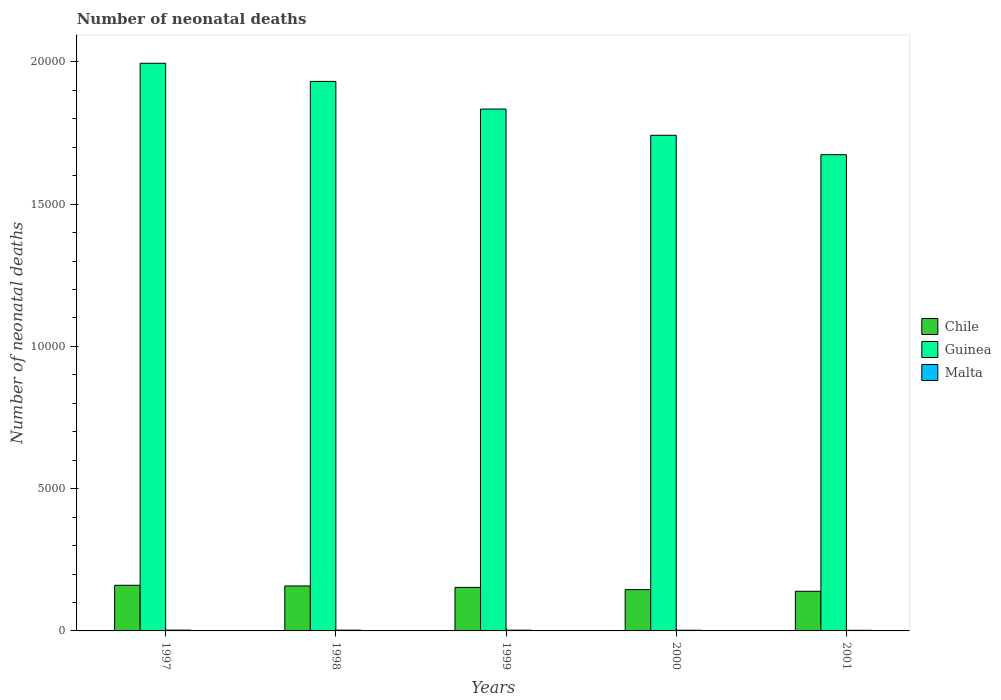How many different coloured bars are there?
Your answer should be compact. 3. How many groups of bars are there?
Make the answer very short. 5. Are the number of bars per tick equal to the number of legend labels?
Keep it short and to the point. Yes. What is the label of the 1st group of bars from the left?
Give a very brief answer. 1997. What is the number of neonatal deaths in in Guinea in 1999?
Provide a succinct answer. 1.83e+04. Across all years, what is the maximum number of neonatal deaths in in Malta?
Your response must be concise. 28. Across all years, what is the minimum number of neonatal deaths in in Malta?
Your response must be concise. 22. What is the total number of neonatal deaths in in Guinea in the graph?
Ensure brevity in your answer.  9.18e+04. What is the difference between the number of neonatal deaths in in Guinea in 2000 and that in 2001?
Ensure brevity in your answer.  682. What is the difference between the number of neonatal deaths in in Malta in 1997 and the number of neonatal deaths in in Guinea in 2001?
Provide a succinct answer. -1.67e+04. What is the average number of neonatal deaths in in Chile per year?
Ensure brevity in your answer.  1512. In the year 1998, what is the difference between the number of neonatal deaths in in Chile and number of neonatal deaths in in Guinea?
Provide a succinct answer. -1.77e+04. In how many years, is the number of neonatal deaths in in Guinea greater than 2000?
Your answer should be compact. 5. What is the ratio of the number of neonatal deaths in in Malta in 1998 to that in 1999?
Your response must be concise. 1.04. Is the number of neonatal deaths in in Guinea in 1998 less than that in 2000?
Your answer should be very brief. No. What is the difference between the highest and the lowest number of neonatal deaths in in Chile?
Ensure brevity in your answer.  210. Is the sum of the number of neonatal deaths in in Chile in 1998 and 1999 greater than the maximum number of neonatal deaths in in Guinea across all years?
Make the answer very short. No. What does the 1st bar from the left in 1999 represents?
Offer a terse response. Chile. What does the 2nd bar from the right in 1998 represents?
Offer a very short reply. Guinea. Is it the case that in every year, the sum of the number of neonatal deaths in in Malta and number of neonatal deaths in in Guinea is greater than the number of neonatal deaths in in Chile?
Give a very brief answer. Yes. How many years are there in the graph?
Ensure brevity in your answer.  5. What is the difference between two consecutive major ticks on the Y-axis?
Provide a succinct answer. 5000. Are the values on the major ticks of Y-axis written in scientific E-notation?
Offer a terse response. No. How many legend labels are there?
Offer a terse response. 3. What is the title of the graph?
Offer a terse response. Number of neonatal deaths. What is the label or title of the Y-axis?
Give a very brief answer. Number of neonatal deaths. What is the Number of neonatal deaths in Chile in 1997?
Offer a terse response. 1604. What is the Number of neonatal deaths of Guinea in 1997?
Your response must be concise. 2.00e+04. What is the Number of neonatal deaths in Chile in 1998?
Offer a very short reply. 1580. What is the Number of neonatal deaths of Guinea in 1998?
Provide a succinct answer. 1.93e+04. What is the Number of neonatal deaths in Chile in 1999?
Give a very brief answer. 1530. What is the Number of neonatal deaths in Guinea in 1999?
Offer a terse response. 1.83e+04. What is the Number of neonatal deaths in Malta in 1999?
Give a very brief answer. 26. What is the Number of neonatal deaths in Chile in 2000?
Ensure brevity in your answer.  1452. What is the Number of neonatal deaths in Guinea in 2000?
Offer a very short reply. 1.74e+04. What is the Number of neonatal deaths of Chile in 2001?
Ensure brevity in your answer.  1394. What is the Number of neonatal deaths of Guinea in 2001?
Your answer should be very brief. 1.67e+04. Across all years, what is the maximum Number of neonatal deaths of Chile?
Give a very brief answer. 1604. Across all years, what is the maximum Number of neonatal deaths in Guinea?
Give a very brief answer. 2.00e+04. Across all years, what is the maximum Number of neonatal deaths in Malta?
Offer a very short reply. 28. Across all years, what is the minimum Number of neonatal deaths of Chile?
Provide a succinct answer. 1394. Across all years, what is the minimum Number of neonatal deaths in Guinea?
Your answer should be compact. 1.67e+04. Across all years, what is the minimum Number of neonatal deaths in Malta?
Your response must be concise. 22. What is the total Number of neonatal deaths in Chile in the graph?
Provide a succinct answer. 7560. What is the total Number of neonatal deaths in Guinea in the graph?
Provide a short and direct response. 9.18e+04. What is the total Number of neonatal deaths of Malta in the graph?
Make the answer very short. 127. What is the difference between the Number of neonatal deaths of Guinea in 1997 and that in 1998?
Your answer should be compact. 637. What is the difference between the Number of neonatal deaths of Guinea in 1997 and that in 1999?
Provide a short and direct response. 1609. What is the difference between the Number of neonatal deaths in Malta in 1997 and that in 1999?
Keep it short and to the point. 2. What is the difference between the Number of neonatal deaths of Chile in 1997 and that in 2000?
Keep it short and to the point. 152. What is the difference between the Number of neonatal deaths of Guinea in 1997 and that in 2000?
Your response must be concise. 2531. What is the difference between the Number of neonatal deaths in Chile in 1997 and that in 2001?
Your response must be concise. 210. What is the difference between the Number of neonatal deaths of Guinea in 1997 and that in 2001?
Provide a short and direct response. 3213. What is the difference between the Number of neonatal deaths of Guinea in 1998 and that in 1999?
Keep it short and to the point. 972. What is the difference between the Number of neonatal deaths of Chile in 1998 and that in 2000?
Your answer should be compact. 128. What is the difference between the Number of neonatal deaths of Guinea in 1998 and that in 2000?
Your response must be concise. 1894. What is the difference between the Number of neonatal deaths of Chile in 1998 and that in 2001?
Your response must be concise. 186. What is the difference between the Number of neonatal deaths in Guinea in 1998 and that in 2001?
Ensure brevity in your answer.  2576. What is the difference between the Number of neonatal deaths of Guinea in 1999 and that in 2000?
Offer a very short reply. 922. What is the difference between the Number of neonatal deaths of Malta in 1999 and that in 2000?
Make the answer very short. 2. What is the difference between the Number of neonatal deaths of Chile in 1999 and that in 2001?
Provide a short and direct response. 136. What is the difference between the Number of neonatal deaths of Guinea in 1999 and that in 2001?
Give a very brief answer. 1604. What is the difference between the Number of neonatal deaths in Malta in 1999 and that in 2001?
Give a very brief answer. 4. What is the difference between the Number of neonatal deaths in Chile in 2000 and that in 2001?
Your answer should be compact. 58. What is the difference between the Number of neonatal deaths in Guinea in 2000 and that in 2001?
Provide a short and direct response. 682. What is the difference between the Number of neonatal deaths of Malta in 2000 and that in 2001?
Keep it short and to the point. 2. What is the difference between the Number of neonatal deaths in Chile in 1997 and the Number of neonatal deaths in Guinea in 1998?
Offer a terse response. -1.77e+04. What is the difference between the Number of neonatal deaths of Chile in 1997 and the Number of neonatal deaths of Malta in 1998?
Keep it short and to the point. 1577. What is the difference between the Number of neonatal deaths in Guinea in 1997 and the Number of neonatal deaths in Malta in 1998?
Keep it short and to the point. 1.99e+04. What is the difference between the Number of neonatal deaths in Chile in 1997 and the Number of neonatal deaths in Guinea in 1999?
Provide a succinct answer. -1.67e+04. What is the difference between the Number of neonatal deaths in Chile in 1997 and the Number of neonatal deaths in Malta in 1999?
Offer a very short reply. 1578. What is the difference between the Number of neonatal deaths of Guinea in 1997 and the Number of neonatal deaths of Malta in 1999?
Give a very brief answer. 1.99e+04. What is the difference between the Number of neonatal deaths of Chile in 1997 and the Number of neonatal deaths of Guinea in 2000?
Provide a short and direct response. -1.58e+04. What is the difference between the Number of neonatal deaths of Chile in 1997 and the Number of neonatal deaths of Malta in 2000?
Provide a short and direct response. 1580. What is the difference between the Number of neonatal deaths in Guinea in 1997 and the Number of neonatal deaths in Malta in 2000?
Give a very brief answer. 1.99e+04. What is the difference between the Number of neonatal deaths of Chile in 1997 and the Number of neonatal deaths of Guinea in 2001?
Offer a terse response. -1.51e+04. What is the difference between the Number of neonatal deaths in Chile in 1997 and the Number of neonatal deaths in Malta in 2001?
Make the answer very short. 1582. What is the difference between the Number of neonatal deaths of Guinea in 1997 and the Number of neonatal deaths of Malta in 2001?
Offer a very short reply. 1.99e+04. What is the difference between the Number of neonatal deaths in Chile in 1998 and the Number of neonatal deaths in Guinea in 1999?
Your answer should be compact. -1.68e+04. What is the difference between the Number of neonatal deaths in Chile in 1998 and the Number of neonatal deaths in Malta in 1999?
Offer a terse response. 1554. What is the difference between the Number of neonatal deaths in Guinea in 1998 and the Number of neonatal deaths in Malta in 1999?
Keep it short and to the point. 1.93e+04. What is the difference between the Number of neonatal deaths of Chile in 1998 and the Number of neonatal deaths of Guinea in 2000?
Offer a very short reply. -1.58e+04. What is the difference between the Number of neonatal deaths of Chile in 1998 and the Number of neonatal deaths of Malta in 2000?
Provide a succinct answer. 1556. What is the difference between the Number of neonatal deaths in Guinea in 1998 and the Number of neonatal deaths in Malta in 2000?
Offer a very short reply. 1.93e+04. What is the difference between the Number of neonatal deaths of Chile in 1998 and the Number of neonatal deaths of Guinea in 2001?
Provide a short and direct response. -1.52e+04. What is the difference between the Number of neonatal deaths in Chile in 1998 and the Number of neonatal deaths in Malta in 2001?
Make the answer very short. 1558. What is the difference between the Number of neonatal deaths in Guinea in 1998 and the Number of neonatal deaths in Malta in 2001?
Offer a very short reply. 1.93e+04. What is the difference between the Number of neonatal deaths in Chile in 1999 and the Number of neonatal deaths in Guinea in 2000?
Offer a terse response. -1.59e+04. What is the difference between the Number of neonatal deaths in Chile in 1999 and the Number of neonatal deaths in Malta in 2000?
Ensure brevity in your answer.  1506. What is the difference between the Number of neonatal deaths of Guinea in 1999 and the Number of neonatal deaths of Malta in 2000?
Keep it short and to the point. 1.83e+04. What is the difference between the Number of neonatal deaths in Chile in 1999 and the Number of neonatal deaths in Guinea in 2001?
Give a very brief answer. -1.52e+04. What is the difference between the Number of neonatal deaths in Chile in 1999 and the Number of neonatal deaths in Malta in 2001?
Provide a succinct answer. 1508. What is the difference between the Number of neonatal deaths in Guinea in 1999 and the Number of neonatal deaths in Malta in 2001?
Your answer should be very brief. 1.83e+04. What is the difference between the Number of neonatal deaths in Chile in 2000 and the Number of neonatal deaths in Guinea in 2001?
Give a very brief answer. -1.53e+04. What is the difference between the Number of neonatal deaths of Chile in 2000 and the Number of neonatal deaths of Malta in 2001?
Provide a succinct answer. 1430. What is the difference between the Number of neonatal deaths in Guinea in 2000 and the Number of neonatal deaths in Malta in 2001?
Offer a terse response. 1.74e+04. What is the average Number of neonatal deaths of Chile per year?
Provide a succinct answer. 1512. What is the average Number of neonatal deaths of Guinea per year?
Offer a very short reply. 1.84e+04. What is the average Number of neonatal deaths of Malta per year?
Keep it short and to the point. 25.4. In the year 1997, what is the difference between the Number of neonatal deaths in Chile and Number of neonatal deaths in Guinea?
Give a very brief answer. -1.83e+04. In the year 1997, what is the difference between the Number of neonatal deaths of Chile and Number of neonatal deaths of Malta?
Keep it short and to the point. 1576. In the year 1997, what is the difference between the Number of neonatal deaths of Guinea and Number of neonatal deaths of Malta?
Your answer should be very brief. 1.99e+04. In the year 1998, what is the difference between the Number of neonatal deaths of Chile and Number of neonatal deaths of Guinea?
Make the answer very short. -1.77e+04. In the year 1998, what is the difference between the Number of neonatal deaths of Chile and Number of neonatal deaths of Malta?
Keep it short and to the point. 1553. In the year 1998, what is the difference between the Number of neonatal deaths of Guinea and Number of neonatal deaths of Malta?
Your response must be concise. 1.93e+04. In the year 1999, what is the difference between the Number of neonatal deaths in Chile and Number of neonatal deaths in Guinea?
Your answer should be compact. -1.68e+04. In the year 1999, what is the difference between the Number of neonatal deaths of Chile and Number of neonatal deaths of Malta?
Offer a terse response. 1504. In the year 1999, what is the difference between the Number of neonatal deaths in Guinea and Number of neonatal deaths in Malta?
Provide a short and direct response. 1.83e+04. In the year 2000, what is the difference between the Number of neonatal deaths in Chile and Number of neonatal deaths in Guinea?
Provide a succinct answer. -1.60e+04. In the year 2000, what is the difference between the Number of neonatal deaths in Chile and Number of neonatal deaths in Malta?
Make the answer very short. 1428. In the year 2000, what is the difference between the Number of neonatal deaths in Guinea and Number of neonatal deaths in Malta?
Give a very brief answer. 1.74e+04. In the year 2001, what is the difference between the Number of neonatal deaths in Chile and Number of neonatal deaths in Guinea?
Offer a terse response. -1.53e+04. In the year 2001, what is the difference between the Number of neonatal deaths in Chile and Number of neonatal deaths in Malta?
Provide a short and direct response. 1372. In the year 2001, what is the difference between the Number of neonatal deaths in Guinea and Number of neonatal deaths in Malta?
Your answer should be compact. 1.67e+04. What is the ratio of the Number of neonatal deaths in Chile in 1997 to that in 1998?
Your response must be concise. 1.02. What is the ratio of the Number of neonatal deaths in Guinea in 1997 to that in 1998?
Provide a short and direct response. 1.03. What is the ratio of the Number of neonatal deaths of Malta in 1997 to that in 1998?
Keep it short and to the point. 1.04. What is the ratio of the Number of neonatal deaths in Chile in 1997 to that in 1999?
Provide a short and direct response. 1.05. What is the ratio of the Number of neonatal deaths in Guinea in 1997 to that in 1999?
Give a very brief answer. 1.09. What is the ratio of the Number of neonatal deaths in Malta in 1997 to that in 1999?
Give a very brief answer. 1.08. What is the ratio of the Number of neonatal deaths in Chile in 1997 to that in 2000?
Your answer should be compact. 1.1. What is the ratio of the Number of neonatal deaths of Guinea in 1997 to that in 2000?
Your answer should be compact. 1.15. What is the ratio of the Number of neonatal deaths of Chile in 1997 to that in 2001?
Ensure brevity in your answer.  1.15. What is the ratio of the Number of neonatal deaths in Guinea in 1997 to that in 2001?
Ensure brevity in your answer.  1.19. What is the ratio of the Number of neonatal deaths in Malta in 1997 to that in 2001?
Your response must be concise. 1.27. What is the ratio of the Number of neonatal deaths in Chile in 1998 to that in 1999?
Provide a short and direct response. 1.03. What is the ratio of the Number of neonatal deaths of Guinea in 1998 to that in 1999?
Keep it short and to the point. 1.05. What is the ratio of the Number of neonatal deaths in Chile in 1998 to that in 2000?
Your response must be concise. 1.09. What is the ratio of the Number of neonatal deaths of Guinea in 1998 to that in 2000?
Provide a short and direct response. 1.11. What is the ratio of the Number of neonatal deaths of Chile in 1998 to that in 2001?
Make the answer very short. 1.13. What is the ratio of the Number of neonatal deaths in Guinea in 1998 to that in 2001?
Provide a succinct answer. 1.15. What is the ratio of the Number of neonatal deaths in Malta in 1998 to that in 2001?
Your response must be concise. 1.23. What is the ratio of the Number of neonatal deaths of Chile in 1999 to that in 2000?
Your answer should be compact. 1.05. What is the ratio of the Number of neonatal deaths of Guinea in 1999 to that in 2000?
Ensure brevity in your answer.  1.05. What is the ratio of the Number of neonatal deaths in Chile in 1999 to that in 2001?
Keep it short and to the point. 1.1. What is the ratio of the Number of neonatal deaths in Guinea in 1999 to that in 2001?
Give a very brief answer. 1.1. What is the ratio of the Number of neonatal deaths of Malta in 1999 to that in 2001?
Give a very brief answer. 1.18. What is the ratio of the Number of neonatal deaths of Chile in 2000 to that in 2001?
Give a very brief answer. 1.04. What is the ratio of the Number of neonatal deaths of Guinea in 2000 to that in 2001?
Offer a very short reply. 1.04. What is the ratio of the Number of neonatal deaths in Malta in 2000 to that in 2001?
Offer a very short reply. 1.09. What is the difference between the highest and the second highest Number of neonatal deaths of Guinea?
Ensure brevity in your answer.  637. What is the difference between the highest and the lowest Number of neonatal deaths in Chile?
Offer a terse response. 210. What is the difference between the highest and the lowest Number of neonatal deaths of Guinea?
Offer a terse response. 3213. 